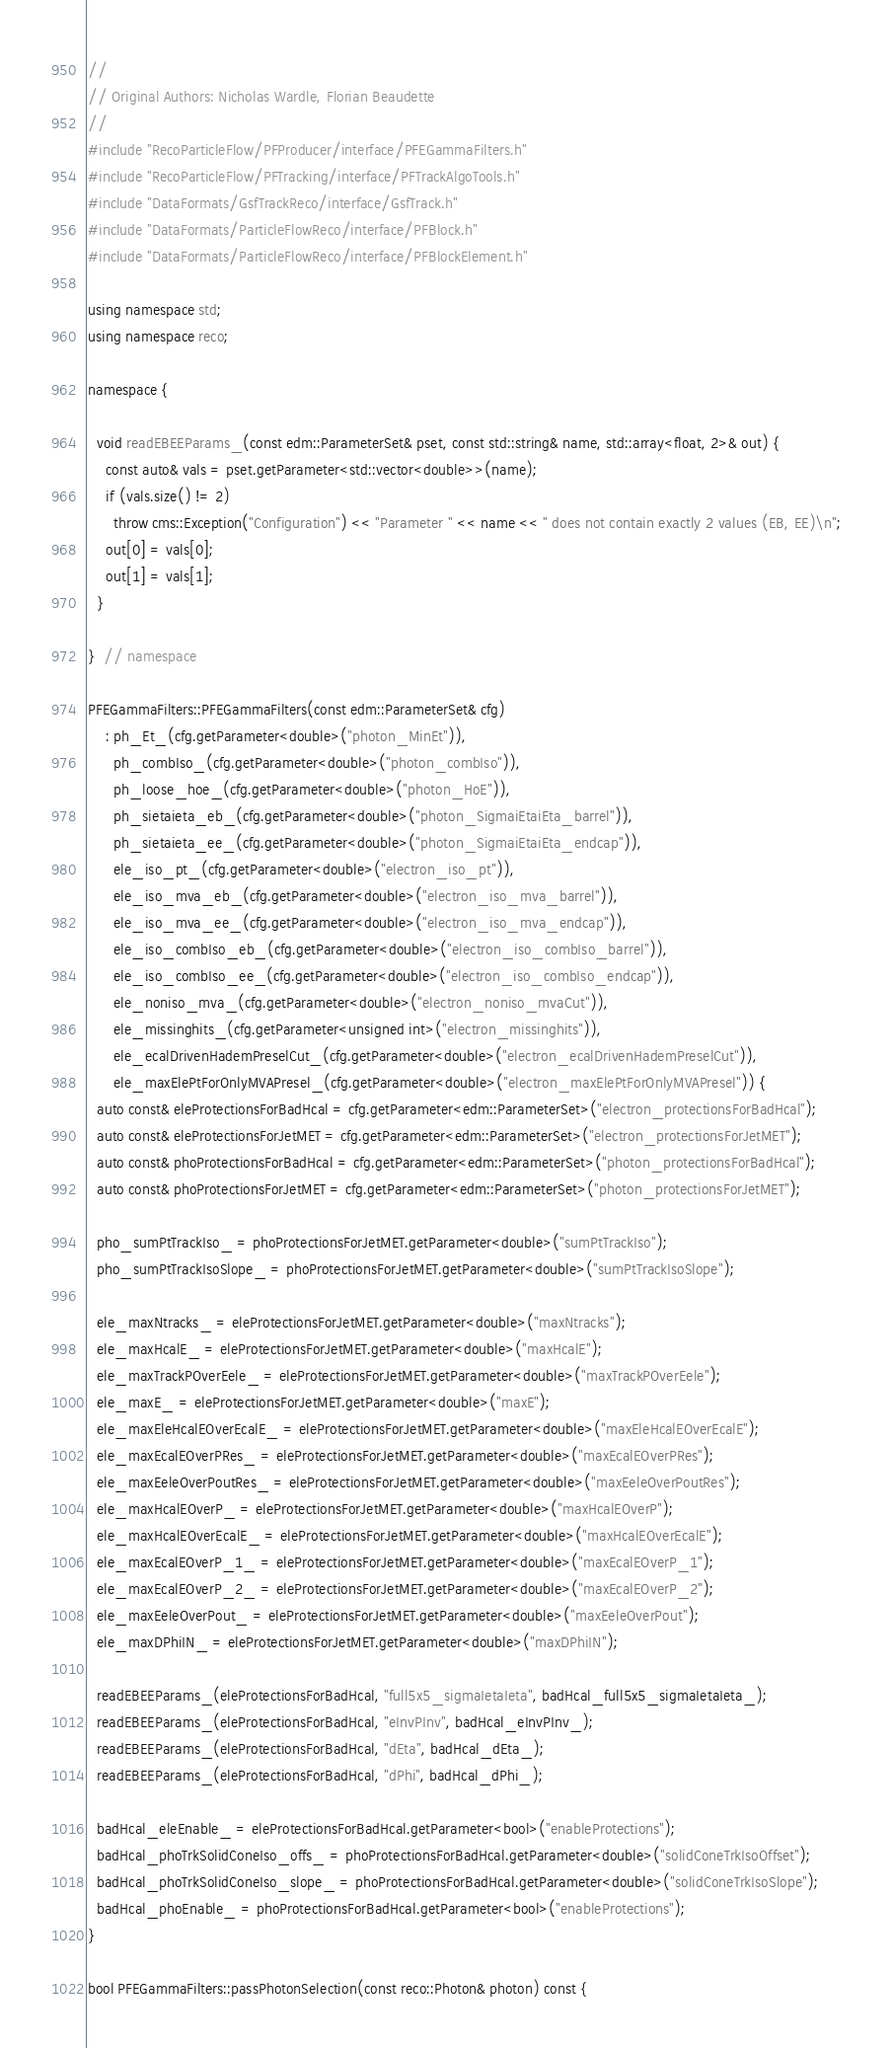<code> <loc_0><loc_0><loc_500><loc_500><_C++_>//
// Original Authors: Nicholas Wardle, Florian Beaudette
//
#include "RecoParticleFlow/PFProducer/interface/PFEGammaFilters.h"
#include "RecoParticleFlow/PFTracking/interface/PFTrackAlgoTools.h"
#include "DataFormats/GsfTrackReco/interface/GsfTrack.h"
#include "DataFormats/ParticleFlowReco/interface/PFBlock.h"
#include "DataFormats/ParticleFlowReco/interface/PFBlockElement.h"

using namespace std;
using namespace reco;

namespace {

  void readEBEEParams_(const edm::ParameterSet& pset, const std::string& name, std::array<float, 2>& out) {
    const auto& vals = pset.getParameter<std::vector<double>>(name);
    if (vals.size() != 2)
      throw cms::Exception("Configuration") << "Parameter " << name << " does not contain exactly 2 values (EB, EE)\n";
    out[0] = vals[0];
    out[1] = vals[1];
  }

}  // namespace

PFEGammaFilters::PFEGammaFilters(const edm::ParameterSet& cfg)
    : ph_Et_(cfg.getParameter<double>("photon_MinEt")),
      ph_combIso_(cfg.getParameter<double>("photon_combIso")),
      ph_loose_hoe_(cfg.getParameter<double>("photon_HoE")),
      ph_sietaieta_eb_(cfg.getParameter<double>("photon_SigmaiEtaiEta_barrel")),
      ph_sietaieta_ee_(cfg.getParameter<double>("photon_SigmaiEtaiEta_endcap")),
      ele_iso_pt_(cfg.getParameter<double>("electron_iso_pt")),
      ele_iso_mva_eb_(cfg.getParameter<double>("electron_iso_mva_barrel")),
      ele_iso_mva_ee_(cfg.getParameter<double>("electron_iso_mva_endcap")),
      ele_iso_combIso_eb_(cfg.getParameter<double>("electron_iso_combIso_barrel")),
      ele_iso_combIso_ee_(cfg.getParameter<double>("electron_iso_combIso_endcap")),
      ele_noniso_mva_(cfg.getParameter<double>("electron_noniso_mvaCut")),
      ele_missinghits_(cfg.getParameter<unsigned int>("electron_missinghits")),
      ele_ecalDrivenHademPreselCut_(cfg.getParameter<double>("electron_ecalDrivenHademPreselCut")),
      ele_maxElePtForOnlyMVAPresel_(cfg.getParameter<double>("electron_maxElePtForOnlyMVAPresel")) {
  auto const& eleProtectionsForBadHcal = cfg.getParameter<edm::ParameterSet>("electron_protectionsForBadHcal");
  auto const& eleProtectionsForJetMET = cfg.getParameter<edm::ParameterSet>("electron_protectionsForJetMET");
  auto const& phoProtectionsForBadHcal = cfg.getParameter<edm::ParameterSet>("photon_protectionsForBadHcal");
  auto const& phoProtectionsForJetMET = cfg.getParameter<edm::ParameterSet>("photon_protectionsForJetMET");

  pho_sumPtTrackIso_ = phoProtectionsForJetMET.getParameter<double>("sumPtTrackIso");
  pho_sumPtTrackIsoSlope_ = phoProtectionsForJetMET.getParameter<double>("sumPtTrackIsoSlope");

  ele_maxNtracks_ = eleProtectionsForJetMET.getParameter<double>("maxNtracks");
  ele_maxHcalE_ = eleProtectionsForJetMET.getParameter<double>("maxHcalE");
  ele_maxTrackPOverEele_ = eleProtectionsForJetMET.getParameter<double>("maxTrackPOverEele");
  ele_maxE_ = eleProtectionsForJetMET.getParameter<double>("maxE");
  ele_maxEleHcalEOverEcalE_ = eleProtectionsForJetMET.getParameter<double>("maxEleHcalEOverEcalE");
  ele_maxEcalEOverPRes_ = eleProtectionsForJetMET.getParameter<double>("maxEcalEOverPRes");
  ele_maxEeleOverPoutRes_ = eleProtectionsForJetMET.getParameter<double>("maxEeleOverPoutRes");
  ele_maxHcalEOverP_ = eleProtectionsForJetMET.getParameter<double>("maxHcalEOverP");
  ele_maxHcalEOverEcalE_ = eleProtectionsForJetMET.getParameter<double>("maxHcalEOverEcalE");
  ele_maxEcalEOverP_1_ = eleProtectionsForJetMET.getParameter<double>("maxEcalEOverP_1");
  ele_maxEcalEOverP_2_ = eleProtectionsForJetMET.getParameter<double>("maxEcalEOverP_2");
  ele_maxEeleOverPout_ = eleProtectionsForJetMET.getParameter<double>("maxEeleOverPout");
  ele_maxDPhiIN_ = eleProtectionsForJetMET.getParameter<double>("maxDPhiIN");

  readEBEEParams_(eleProtectionsForBadHcal, "full5x5_sigmaIetaIeta", badHcal_full5x5_sigmaIetaIeta_);
  readEBEEParams_(eleProtectionsForBadHcal, "eInvPInv", badHcal_eInvPInv_);
  readEBEEParams_(eleProtectionsForBadHcal, "dEta", badHcal_dEta_);
  readEBEEParams_(eleProtectionsForBadHcal, "dPhi", badHcal_dPhi_);

  badHcal_eleEnable_ = eleProtectionsForBadHcal.getParameter<bool>("enableProtections");
  badHcal_phoTrkSolidConeIso_offs_ = phoProtectionsForBadHcal.getParameter<double>("solidConeTrkIsoOffset");
  badHcal_phoTrkSolidConeIso_slope_ = phoProtectionsForBadHcal.getParameter<double>("solidConeTrkIsoSlope");
  badHcal_phoEnable_ = phoProtectionsForBadHcal.getParameter<bool>("enableProtections");
}

bool PFEGammaFilters::passPhotonSelection(const reco::Photon& photon) const {</code> 